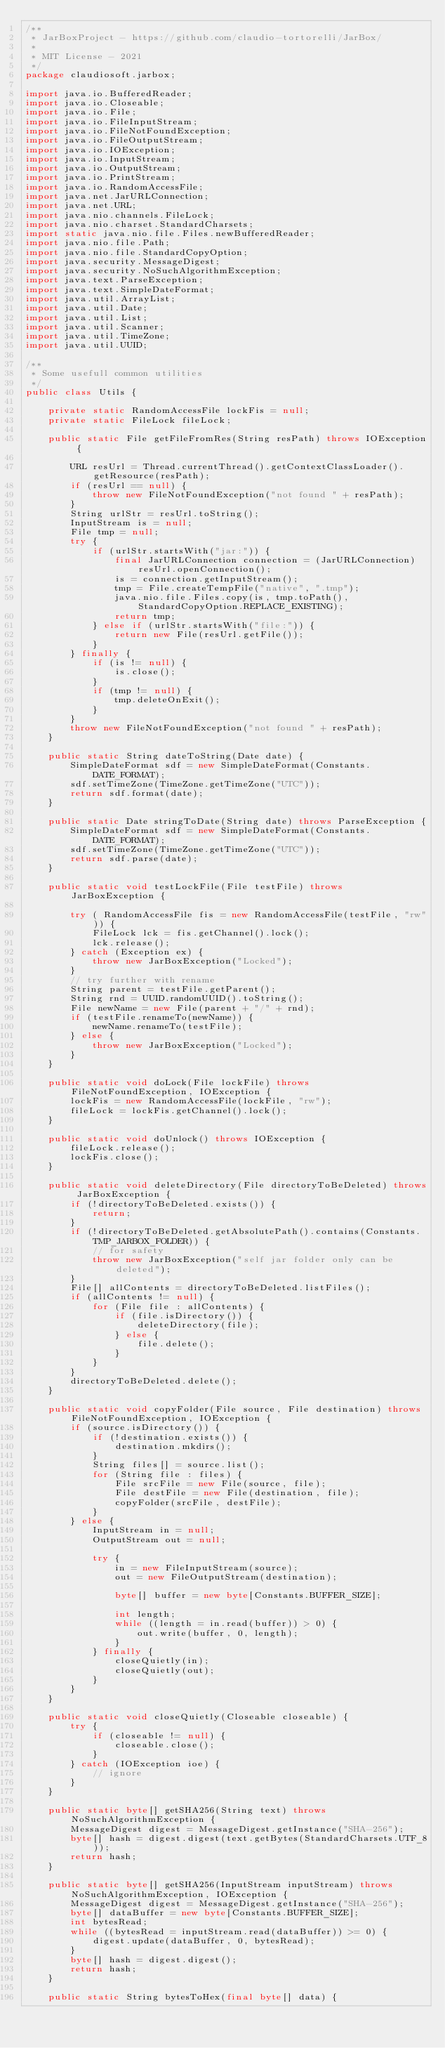<code> <loc_0><loc_0><loc_500><loc_500><_Java_>/**
 * JarBoxProject - https://github.com/claudio-tortorelli/JarBox/
 *
 * MIT License - 2021
 */
package claudiosoft.jarbox;

import java.io.BufferedReader;
import java.io.Closeable;
import java.io.File;
import java.io.FileInputStream;
import java.io.FileNotFoundException;
import java.io.FileOutputStream;
import java.io.IOException;
import java.io.InputStream;
import java.io.OutputStream;
import java.io.PrintStream;
import java.io.RandomAccessFile;
import java.net.JarURLConnection;
import java.net.URL;
import java.nio.channels.FileLock;
import java.nio.charset.StandardCharsets;
import static java.nio.file.Files.newBufferedReader;
import java.nio.file.Path;
import java.nio.file.StandardCopyOption;
import java.security.MessageDigest;
import java.security.NoSuchAlgorithmException;
import java.text.ParseException;
import java.text.SimpleDateFormat;
import java.util.ArrayList;
import java.util.Date;
import java.util.List;
import java.util.Scanner;
import java.util.TimeZone;
import java.util.UUID;

/**
 * Some usefull common utilities
 */
public class Utils {

    private static RandomAccessFile lockFis = null;
    private static FileLock fileLock;

    public static File getFileFromRes(String resPath) throws IOException {

        URL resUrl = Thread.currentThread().getContextClassLoader().getResource(resPath);
        if (resUrl == null) {
            throw new FileNotFoundException("not found " + resPath);
        }
        String urlStr = resUrl.toString();
        InputStream is = null;
        File tmp = null;
        try {
            if (urlStr.startsWith("jar:")) {
                final JarURLConnection connection = (JarURLConnection) resUrl.openConnection();
                is = connection.getInputStream();
                tmp = File.createTempFile("native", ".tmp");
                java.nio.file.Files.copy(is, tmp.toPath(), StandardCopyOption.REPLACE_EXISTING);
                return tmp;
            } else if (urlStr.startsWith("file:")) {
                return new File(resUrl.getFile());
            }
        } finally {
            if (is != null) {
                is.close();
            }
            if (tmp != null) {
                tmp.deleteOnExit();
            }
        }
        throw new FileNotFoundException("not found " + resPath);
    }

    public static String dateToString(Date date) {
        SimpleDateFormat sdf = new SimpleDateFormat(Constants.DATE_FORMAT);
        sdf.setTimeZone(TimeZone.getTimeZone("UTC"));
        return sdf.format(date);
    }

    public static Date stringToDate(String date) throws ParseException {
        SimpleDateFormat sdf = new SimpleDateFormat(Constants.DATE_FORMAT);
        sdf.setTimeZone(TimeZone.getTimeZone("UTC"));
        return sdf.parse(date);
    }

    public static void testLockFile(File testFile) throws JarBoxException {

        try ( RandomAccessFile fis = new RandomAccessFile(testFile, "rw")) {
            FileLock lck = fis.getChannel().lock();
            lck.release();
        } catch (Exception ex) {
            throw new JarBoxException("Locked");
        }
        // try further with rename
        String parent = testFile.getParent();
        String rnd = UUID.randomUUID().toString();
        File newName = new File(parent + "/" + rnd);
        if (testFile.renameTo(newName)) {
            newName.renameTo(testFile);
        } else {
            throw new JarBoxException("Locked");
        }
    }

    public static void doLock(File lockFile) throws FileNotFoundException, IOException {
        lockFis = new RandomAccessFile(lockFile, "rw");
        fileLock = lockFis.getChannel().lock();
    }

    public static void doUnlock() throws IOException {
        fileLock.release();
        lockFis.close();
    }

    public static void deleteDirectory(File directoryToBeDeleted) throws JarBoxException {
        if (!directoryToBeDeleted.exists()) {
            return;
        }
        if (!directoryToBeDeleted.getAbsolutePath().contains(Constants.TMP_JARBOX_FOLDER)) {
            // for safety
            throw new JarBoxException("self jar folder only can be deleted");
        }
        File[] allContents = directoryToBeDeleted.listFiles();
        if (allContents != null) {
            for (File file : allContents) {
                if (file.isDirectory()) {
                    deleteDirectory(file);
                } else {
                    file.delete();
                }
            }
        }
        directoryToBeDeleted.delete();
    }

    public static void copyFolder(File source, File destination) throws FileNotFoundException, IOException {
        if (source.isDirectory()) {
            if (!destination.exists()) {
                destination.mkdirs();
            }
            String files[] = source.list();
            for (String file : files) {
                File srcFile = new File(source, file);
                File destFile = new File(destination, file);
                copyFolder(srcFile, destFile);
            }
        } else {
            InputStream in = null;
            OutputStream out = null;

            try {
                in = new FileInputStream(source);
                out = new FileOutputStream(destination);

                byte[] buffer = new byte[Constants.BUFFER_SIZE];

                int length;
                while ((length = in.read(buffer)) > 0) {
                    out.write(buffer, 0, length);
                }
            } finally {
                closeQuietly(in);
                closeQuietly(out);
            }
        }
    }

    public static void closeQuietly(Closeable closeable) {
        try {
            if (closeable != null) {
                closeable.close();
            }
        } catch (IOException ioe) {
            // ignore
        }
    }

    public static byte[] getSHA256(String text) throws NoSuchAlgorithmException {
        MessageDigest digest = MessageDigest.getInstance("SHA-256");
        byte[] hash = digest.digest(text.getBytes(StandardCharsets.UTF_8));
        return hash;
    }

    public static byte[] getSHA256(InputStream inputStream) throws NoSuchAlgorithmException, IOException {
        MessageDigest digest = MessageDigest.getInstance("SHA-256");
        byte[] dataBuffer = new byte[Constants.BUFFER_SIZE];
        int bytesRead;
        while ((bytesRead = inputStream.read(dataBuffer)) >= 0) {
            digest.update(dataBuffer, 0, bytesRead);
        }
        byte[] hash = digest.digest();
        return hash;
    }

    public static String bytesToHex(final byte[] data) {</code> 